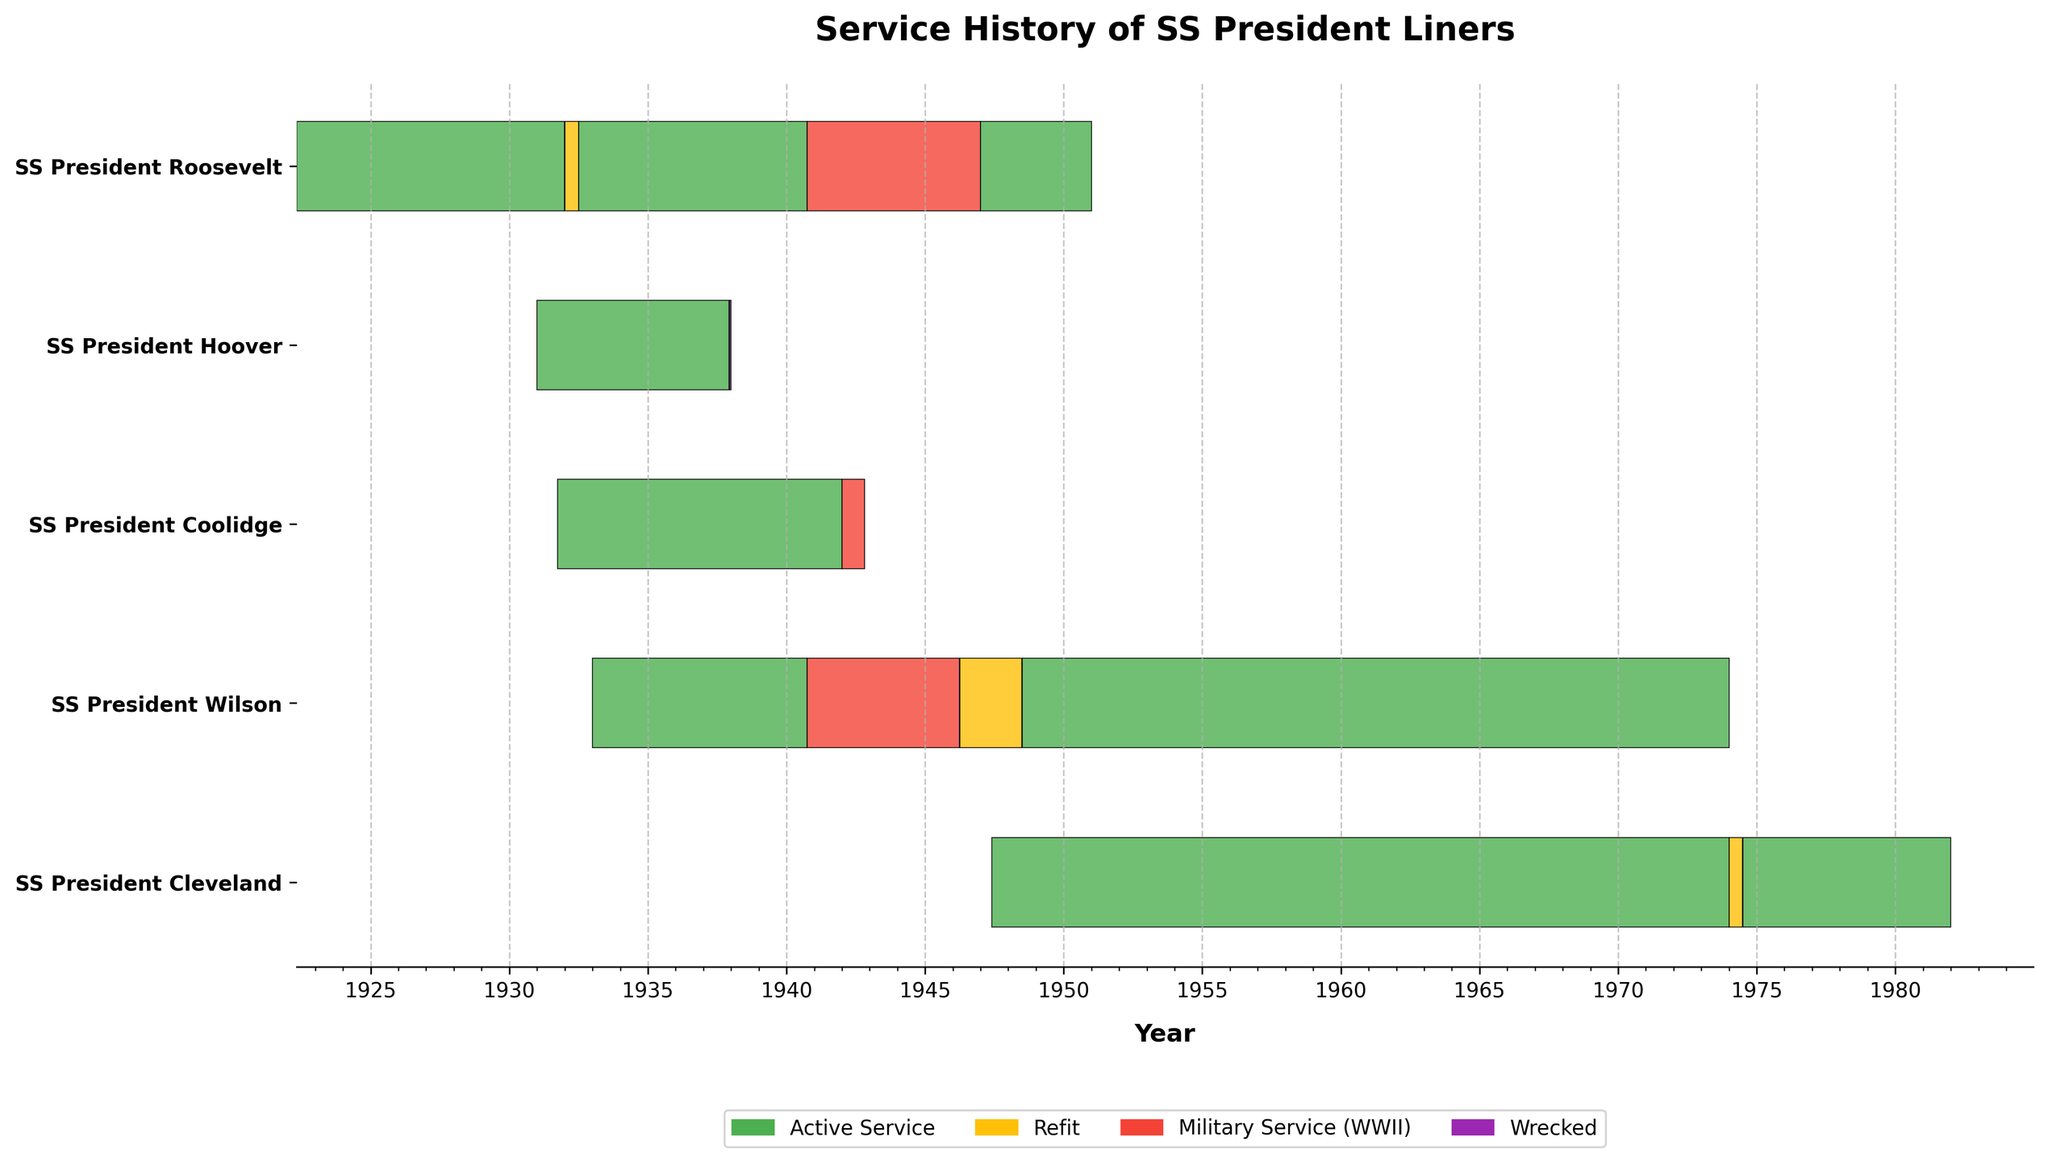What is the title of the Gantt chart? The chart's title is located at the top center of the figure and provides a summary of what the chart depicts.
Answer: Service History of SS President Liners Which ship has the longest period of Active Service? By examining the bars colored in green, you can compare the duration of the green bars for each ship. The longest green bar belongs to SS President Wilson.
Answer: SS President Wilson How many ships served during World War II? Look for the bars colored in red, which represent Military Service (WWII), and count how many unique ships have these red bars.
Answer: 3 For how many years did the SS President Cleveland serve after its refit in 1974? Identify the yellow bar for the refit of SS President Cleveland and measure the length of the subsequent green bar representing Active Service. The green bar from 1974 to 1981 spans 7 years.
Answer: 7 years Which ship had the shortest service period before being wrecked? Look for the purple bar labeled 'Wrecked' and check the duration of Active Service immediately before it. SS President Hoover was in Active Service from January 1931 to December 1937, totaling 6 years and 7 days.
Answer: SS President Hoover What was the total number of years the SS President Roosevelt was in active service? Sum the durations of green bars for SS President Roosevelt: 1922-1931 (9 years), 1932-1940 (8 years), and 1947-1950 (4 years). The total is 21 years.
Answer: 21 years Compare the active service periods of SS President Wilson before and after its refit. Which period was longer? SS President Wilson had Active Service from 1933-1940 (7 years) before the refit and from 1948-1973 (25 years) after the refit. Post-refit service is longer.
Answer: After How many times did the SS President Roosevelt undergo a refit? Look for yellow bars corresponding to SS President Roosevelt and count them. There is one such yellow bar.
Answer: 1 Which ship had the longest continuous Active Service without breaks for refit or war service? Identify the single longest green bar in the chart. The longest green bar without interruption belongs to SS President Cleveland from 1947 to 1973, spanning 26 years.
Answer: SS President Cleveland In which year did SS President Coolidge transition to military service during WWII? Identify the transition from green to red for SS President Coolidge and note the year. This transition occurs in 1942.
Answer: 1942 